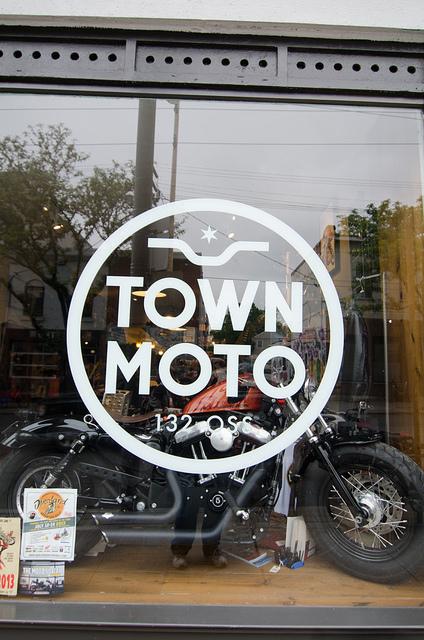What is the significance of the logo on the window to the object behind the glass?
Write a very short answer. Type of store. Can you see a reflection on the window?
Concise answer only. Yes. What does the sign say?
Quick response, please. Town moto. 